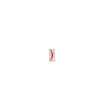<code> <loc_0><loc_0><loc_500><loc_500><_CMake_>)
</code> 